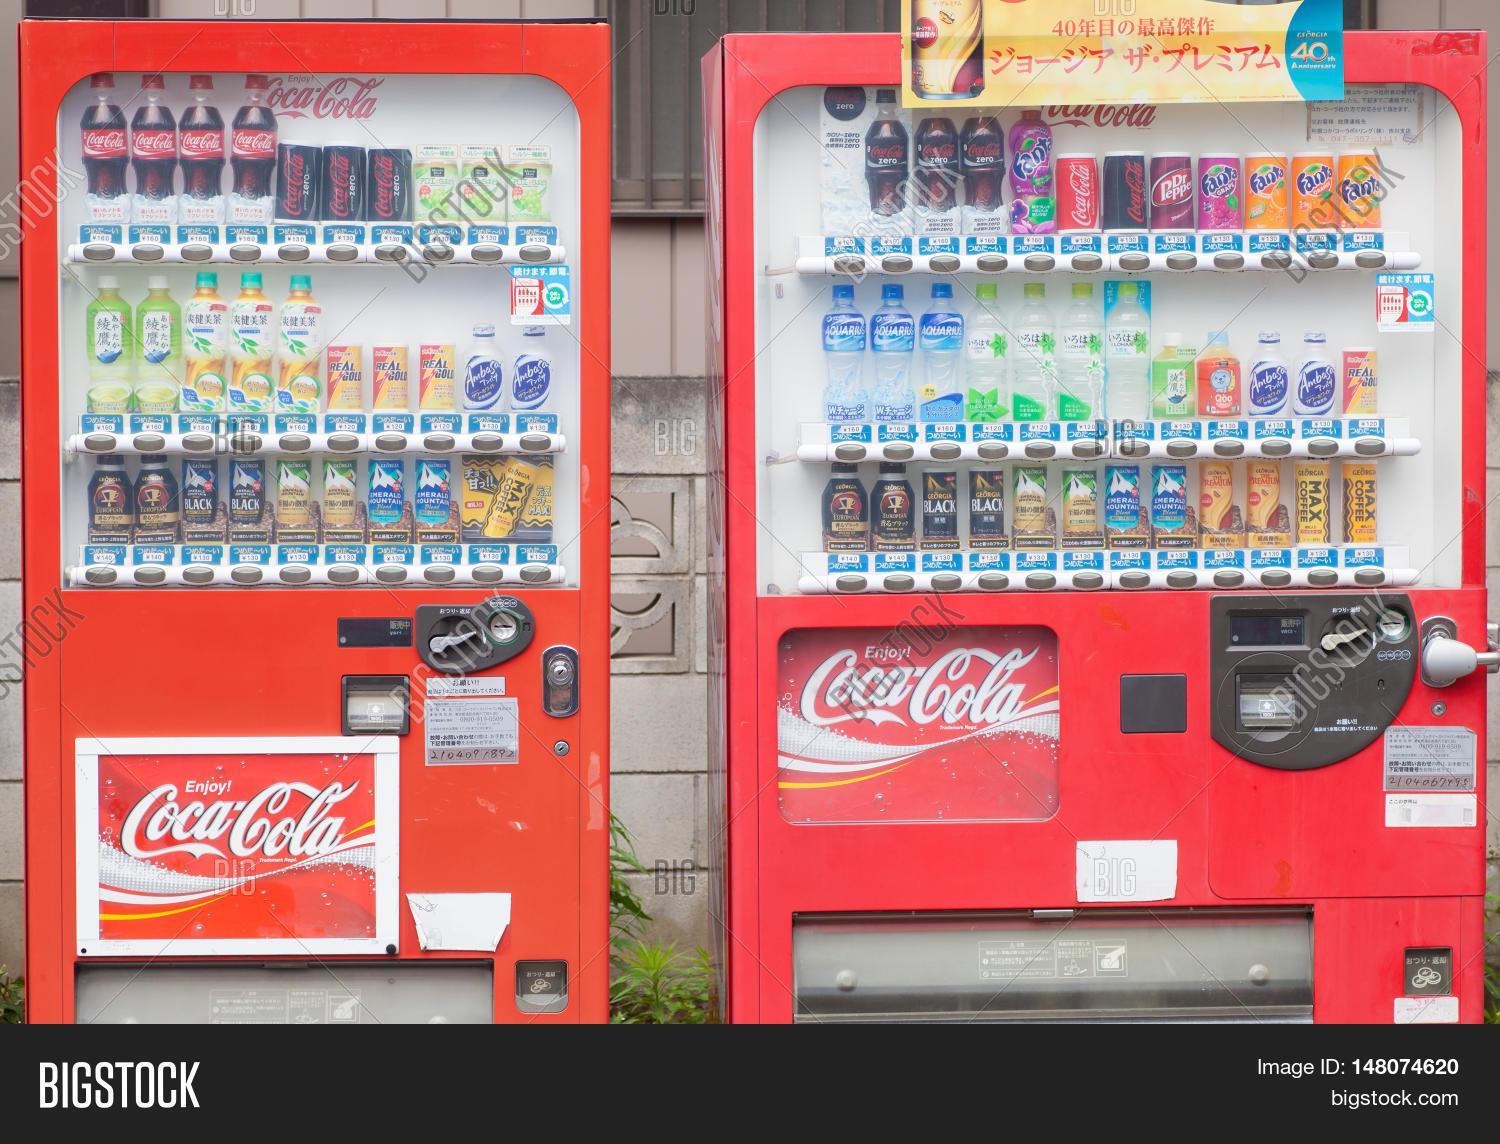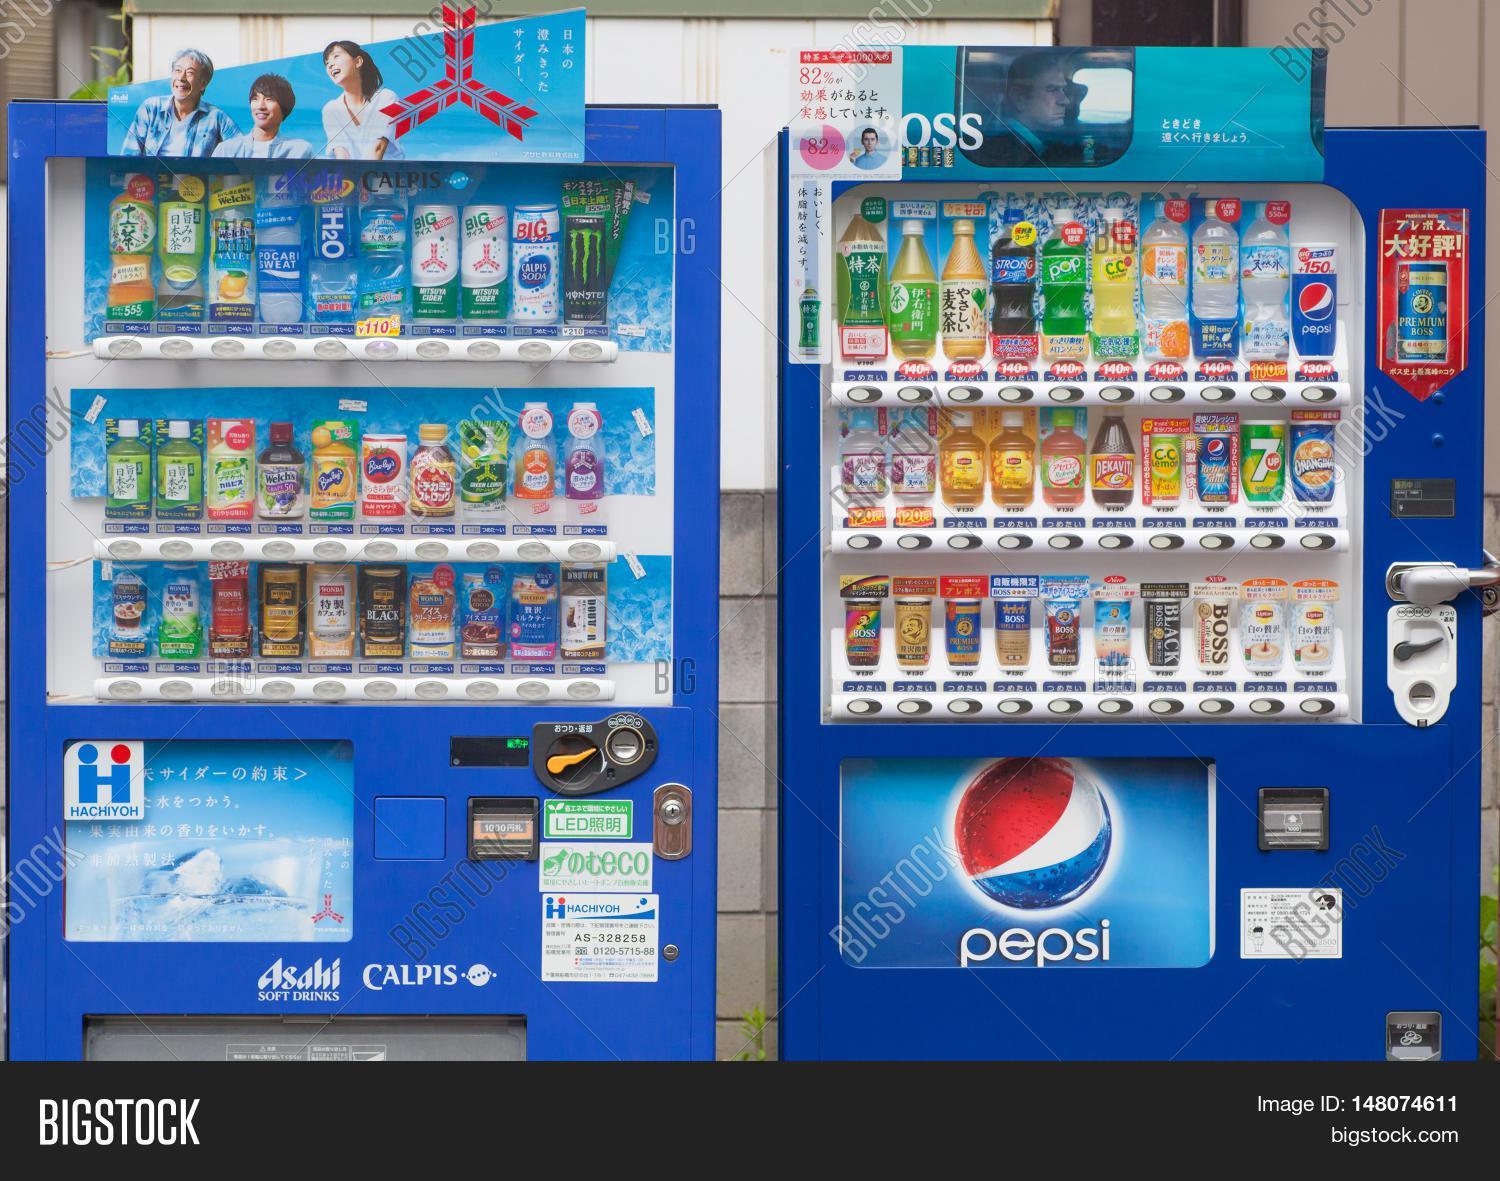The first image is the image on the left, the second image is the image on the right. Given the left and right images, does the statement "An image is focused on one vending machine, which features on its front large Asian characters on a field of red, yellow and blue stripes." hold true? Answer yes or no. No. The first image is the image on the left, the second image is the image on the right. Assess this claim about the two images: "The left image contains a single vending machine.". Correct or not? Answer yes or no. No. 